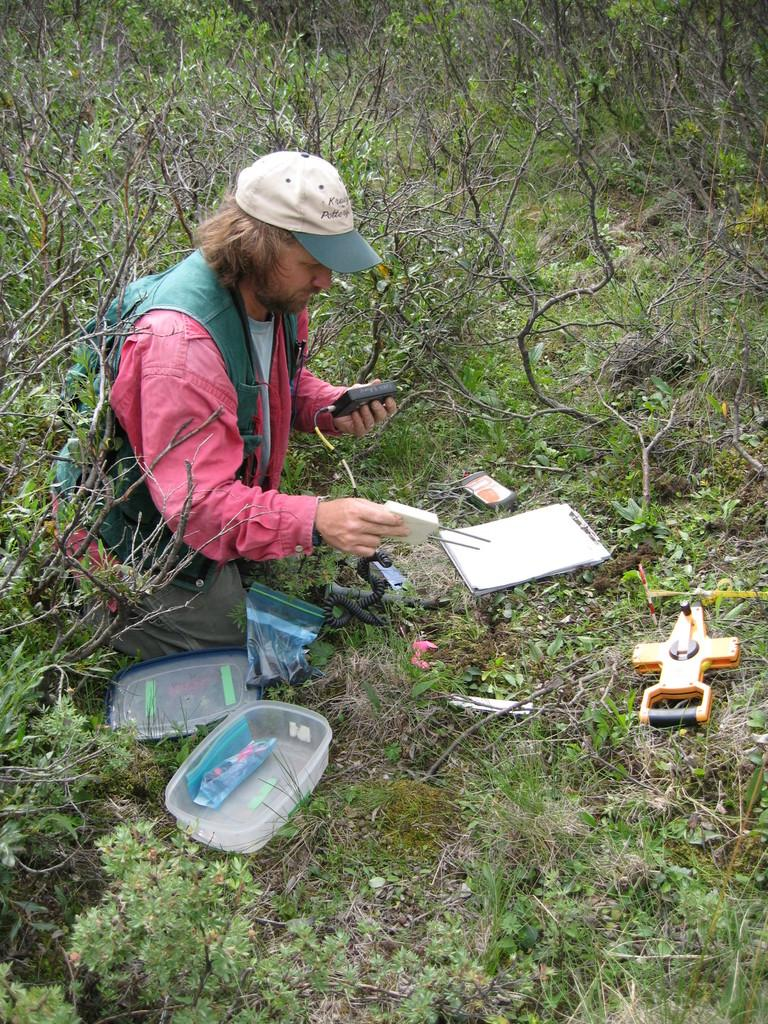What is the primary subject in the image? There is a person in the image. What is the person doing in the image? The person is sitting on their knees on the grass. What is the person holding in the image? The person is holding two objects. What can be seen on the wooden plank in the image? There are papers on a wooden plank. What type of container is present in the image? There is a box in the image. What is the box's lid doing in the image? There is a lid in the image. What is present on the grass in the image? There are objects on the grass. What type of vegetation is visible in the image? There are plants in the image. What type of organization is the person working for in the image? There is no indication in the image that the person is working for any organization. 